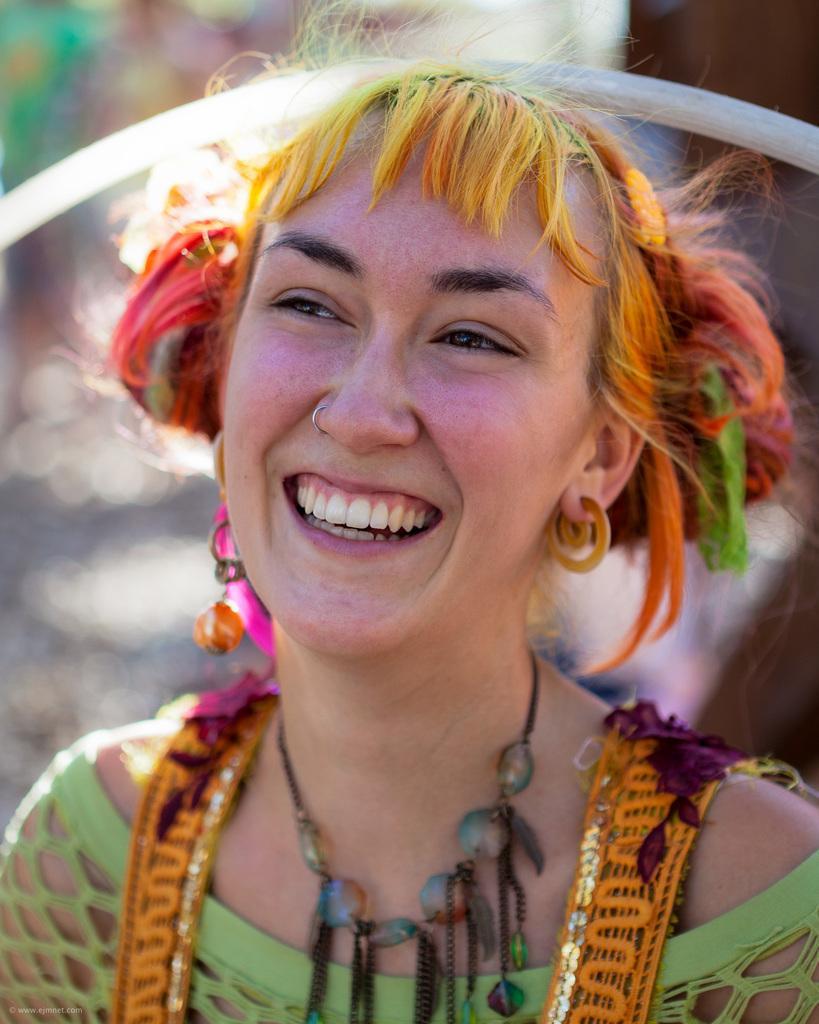Could you give a brief overview of what you see in this image? In the picture I can see a woman is smiling. The woman is wearing a necklace and some other objects. The background of the image is blurred. 